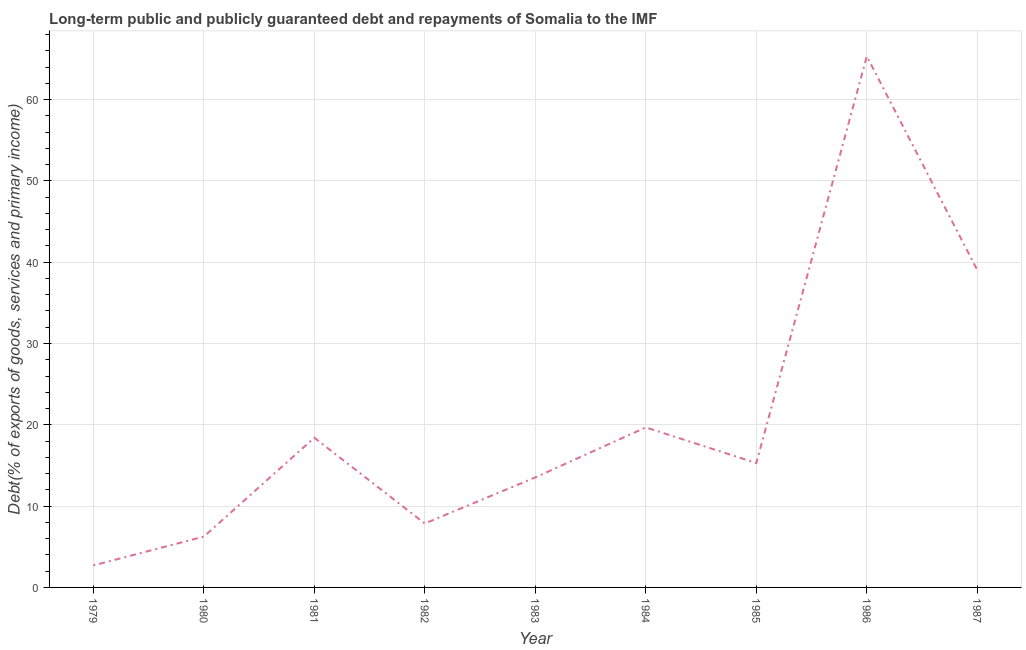What is the debt service in 1979?
Provide a succinct answer. 2.71. Across all years, what is the maximum debt service?
Make the answer very short. 65.33. Across all years, what is the minimum debt service?
Provide a short and direct response. 2.71. In which year was the debt service maximum?
Make the answer very short. 1986. In which year was the debt service minimum?
Provide a short and direct response. 1979. What is the sum of the debt service?
Keep it short and to the point. 188.1. What is the difference between the debt service in 1982 and 1985?
Ensure brevity in your answer.  -7.43. What is the average debt service per year?
Your answer should be compact. 20.9. What is the median debt service?
Provide a short and direct response. 15.3. In how many years, is the debt service greater than 66 %?
Offer a very short reply. 0. What is the ratio of the debt service in 1980 to that in 1987?
Keep it short and to the point. 0.16. Is the difference between the debt service in 1980 and 1985 greater than the difference between any two years?
Offer a very short reply. No. What is the difference between the highest and the second highest debt service?
Give a very brief answer. 26.3. Is the sum of the debt service in 1981 and 1986 greater than the maximum debt service across all years?
Your response must be concise. Yes. What is the difference between the highest and the lowest debt service?
Give a very brief answer. 62.62. In how many years, is the debt service greater than the average debt service taken over all years?
Your answer should be compact. 2. How many lines are there?
Your answer should be compact. 1. What is the difference between two consecutive major ticks on the Y-axis?
Ensure brevity in your answer.  10. Are the values on the major ticks of Y-axis written in scientific E-notation?
Give a very brief answer. No. Does the graph contain any zero values?
Your answer should be very brief. No. What is the title of the graph?
Your response must be concise. Long-term public and publicly guaranteed debt and repayments of Somalia to the IMF. What is the label or title of the Y-axis?
Ensure brevity in your answer.  Debt(% of exports of goods, services and primary income). What is the Debt(% of exports of goods, services and primary income) in 1979?
Your answer should be compact. 2.71. What is the Debt(% of exports of goods, services and primary income) of 1980?
Give a very brief answer. 6.25. What is the Debt(% of exports of goods, services and primary income) of 1981?
Offer a very short reply. 18.41. What is the Debt(% of exports of goods, services and primary income) of 1982?
Offer a very short reply. 7.86. What is the Debt(% of exports of goods, services and primary income) of 1983?
Ensure brevity in your answer.  13.53. What is the Debt(% of exports of goods, services and primary income) in 1984?
Provide a short and direct response. 19.68. What is the Debt(% of exports of goods, services and primary income) in 1985?
Your response must be concise. 15.3. What is the Debt(% of exports of goods, services and primary income) in 1986?
Your answer should be compact. 65.33. What is the Debt(% of exports of goods, services and primary income) in 1987?
Your answer should be compact. 39.03. What is the difference between the Debt(% of exports of goods, services and primary income) in 1979 and 1980?
Offer a very short reply. -3.54. What is the difference between the Debt(% of exports of goods, services and primary income) in 1979 and 1981?
Make the answer very short. -15.7. What is the difference between the Debt(% of exports of goods, services and primary income) in 1979 and 1982?
Your answer should be compact. -5.16. What is the difference between the Debt(% of exports of goods, services and primary income) in 1979 and 1983?
Offer a very short reply. -10.83. What is the difference between the Debt(% of exports of goods, services and primary income) in 1979 and 1984?
Provide a short and direct response. -16.98. What is the difference between the Debt(% of exports of goods, services and primary income) in 1979 and 1985?
Provide a short and direct response. -12.59. What is the difference between the Debt(% of exports of goods, services and primary income) in 1979 and 1986?
Your response must be concise. -62.62. What is the difference between the Debt(% of exports of goods, services and primary income) in 1979 and 1987?
Provide a succinct answer. -36.32. What is the difference between the Debt(% of exports of goods, services and primary income) in 1980 and 1981?
Your answer should be very brief. -12.16. What is the difference between the Debt(% of exports of goods, services and primary income) in 1980 and 1982?
Your answer should be very brief. -1.61. What is the difference between the Debt(% of exports of goods, services and primary income) in 1980 and 1983?
Offer a very short reply. -7.28. What is the difference between the Debt(% of exports of goods, services and primary income) in 1980 and 1984?
Offer a terse response. -13.43. What is the difference between the Debt(% of exports of goods, services and primary income) in 1980 and 1985?
Ensure brevity in your answer.  -9.05. What is the difference between the Debt(% of exports of goods, services and primary income) in 1980 and 1986?
Provide a succinct answer. -59.08. What is the difference between the Debt(% of exports of goods, services and primary income) in 1980 and 1987?
Ensure brevity in your answer.  -32.77. What is the difference between the Debt(% of exports of goods, services and primary income) in 1981 and 1982?
Your answer should be very brief. 10.54. What is the difference between the Debt(% of exports of goods, services and primary income) in 1981 and 1983?
Your answer should be compact. 4.88. What is the difference between the Debt(% of exports of goods, services and primary income) in 1981 and 1984?
Give a very brief answer. -1.27. What is the difference between the Debt(% of exports of goods, services and primary income) in 1981 and 1985?
Keep it short and to the point. 3.11. What is the difference between the Debt(% of exports of goods, services and primary income) in 1981 and 1986?
Your answer should be compact. -46.92. What is the difference between the Debt(% of exports of goods, services and primary income) in 1981 and 1987?
Provide a succinct answer. -20.62. What is the difference between the Debt(% of exports of goods, services and primary income) in 1982 and 1983?
Your answer should be compact. -5.67. What is the difference between the Debt(% of exports of goods, services and primary income) in 1982 and 1984?
Provide a succinct answer. -11.82. What is the difference between the Debt(% of exports of goods, services and primary income) in 1982 and 1985?
Ensure brevity in your answer.  -7.43. What is the difference between the Debt(% of exports of goods, services and primary income) in 1982 and 1986?
Offer a very short reply. -57.46. What is the difference between the Debt(% of exports of goods, services and primary income) in 1982 and 1987?
Keep it short and to the point. -31.16. What is the difference between the Debt(% of exports of goods, services and primary income) in 1983 and 1984?
Offer a very short reply. -6.15. What is the difference between the Debt(% of exports of goods, services and primary income) in 1983 and 1985?
Give a very brief answer. -1.76. What is the difference between the Debt(% of exports of goods, services and primary income) in 1983 and 1986?
Your answer should be compact. -51.79. What is the difference between the Debt(% of exports of goods, services and primary income) in 1983 and 1987?
Your answer should be very brief. -25.49. What is the difference between the Debt(% of exports of goods, services and primary income) in 1984 and 1985?
Make the answer very short. 4.38. What is the difference between the Debt(% of exports of goods, services and primary income) in 1984 and 1986?
Your answer should be very brief. -45.65. What is the difference between the Debt(% of exports of goods, services and primary income) in 1984 and 1987?
Ensure brevity in your answer.  -19.34. What is the difference between the Debt(% of exports of goods, services and primary income) in 1985 and 1986?
Your response must be concise. -50.03. What is the difference between the Debt(% of exports of goods, services and primary income) in 1985 and 1987?
Ensure brevity in your answer.  -23.73. What is the difference between the Debt(% of exports of goods, services and primary income) in 1986 and 1987?
Provide a short and direct response. 26.3. What is the ratio of the Debt(% of exports of goods, services and primary income) in 1979 to that in 1980?
Your answer should be very brief. 0.43. What is the ratio of the Debt(% of exports of goods, services and primary income) in 1979 to that in 1981?
Your answer should be compact. 0.15. What is the ratio of the Debt(% of exports of goods, services and primary income) in 1979 to that in 1982?
Offer a terse response. 0.34. What is the ratio of the Debt(% of exports of goods, services and primary income) in 1979 to that in 1984?
Offer a very short reply. 0.14. What is the ratio of the Debt(% of exports of goods, services and primary income) in 1979 to that in 1985?
Offer a very short reply. 0.18. What is the ratio of the Debt(% of exports of goods, services and primary income) in 1979 to that in 1986?
Your response must be concise. 0.04. What is the ratio of the Debt(% of exports of goods, services and primary income) in 1979 to that in 1987?
Make the answer very short. 0.07. What is the ratio of the Debt(% of exports of goods, services and primary income) in 1980 to that in 1981?
Offer a very short reply. 0.34. What is the ratio of the Debt(% of exports of goods, services and primary income) in 1980 to that in 1982?
Your answer should be compact. 0.8. What is the ratio of the Debt(% of exports of goods, services and primary income) in 1980 to that in 1983?
Your answer should be compact. 0.46. What is the ratio of the Debt(% of exports of goods, services and primary income) in 1980 to that in 1984?
Make the answer very short. 0.32. What is the ratio of the Debt(% of exports of goods, services and primary income) in 1980 to that in 1985?
Offer a terse response. 0.41. What is the ratio of the Debt(% of exports of goods, services and primary income) in 1980 to that in 1986?
Give a very brief answer. 0.1. What is the ratio of the Debt(% of exports of goods, services and primary income) in 1980 to that in 1987?
Your answer should be compact. 0.16. What is the ratio of the Debt(% of exports of goods, services and primary income) in 1981 to that in 1982?
Keep it short and to the point. 2.34. What is the ratio of the Debt(% of exports of goods, services and primary income) in 1981 to that in 1983?
Offer a very short reply. 1.36. What is the ratio of the Debt(% of exports of goods, services and primary income) in 1981 to that in 1984?
Make the answer very short. 0.94. What is the ratio of the Debt(% of exports of goods, services and primary income) in 1981 to that in 1985?
Provide a succinct answer. 1.2. What is the ratio of the Debt(% of exports of goods, services and primary income) in 1981 to that in 1986?
Offer a very short reply. 0.28. What is the ratio of the Debt(% of exports of goods, services and primary income) in 1981 to that in 1987?
Your answer should be compact. 0.47. What is the ratio of the Debt(% of exports of goods, services and primary income) in 1982 to that in 1983?
Give a very brief answer. 0.58. What is the ratio of the Debt(% of exports of goods, services and primary income) in 1982 to that in 1985?
Offer a terse response. 0.51. What is the ratio of the Debt(% of exports of goods, services and primary income) in 1982 to that in 1986?
Give a very brief answer. 0.12. What is the ratio of the Debt(% of exports of goods, services and primary income) in 1982 to that in 1987?
Your answer should be very brief. 0.2. What is the ratio of the Debt(% of exports of goods, services and primary income) in 1983 to that in 1984?
Your answer should be compact. 0.69. What is the ratio of the Debt(% of exports of goods, services and primary income) in 1983 to that in 1985?
Give a very brief answer. 0.89. What is the ratio of the Debt(% of exports of goods, services and primary income) in 1983 to that in 1986?
Provide a succinct answer. 0.21. What is the ratio of the Debt(% of exports of goods, services and primary income) in 1983 to that in 1987?
Keep it short and to the point. 0.35. What is the ratio of the Debt(% of exports of goods, services and primary income) in 1984 to that in 1985?
Offer a very short reply. 1.29. What is the ratio of the Debt(% of exports of goods, services and primary income) in 1984 to that in 1986?
Your answer should be compact. 0.3. What is the ratio of the Debt(% of exports of goods, services and primary income) in 1984 to that in 1987?
Provide a succinct answer. 0.5. What is the ratio of the Debt(% of exports of goods, services and primary income) in 1985 to that in 1986?
Offer a terse response. 0.23. What is the ratio of the Debt(% of exports of goods, services and primary income) in 1985 to that in 1987?
Your response must be concise. 0.39. What is the ratio of the Debt(% of exports of goods, services and primary income) in 1986 to that in 1987?
Offer a very short reply. 1.67. 